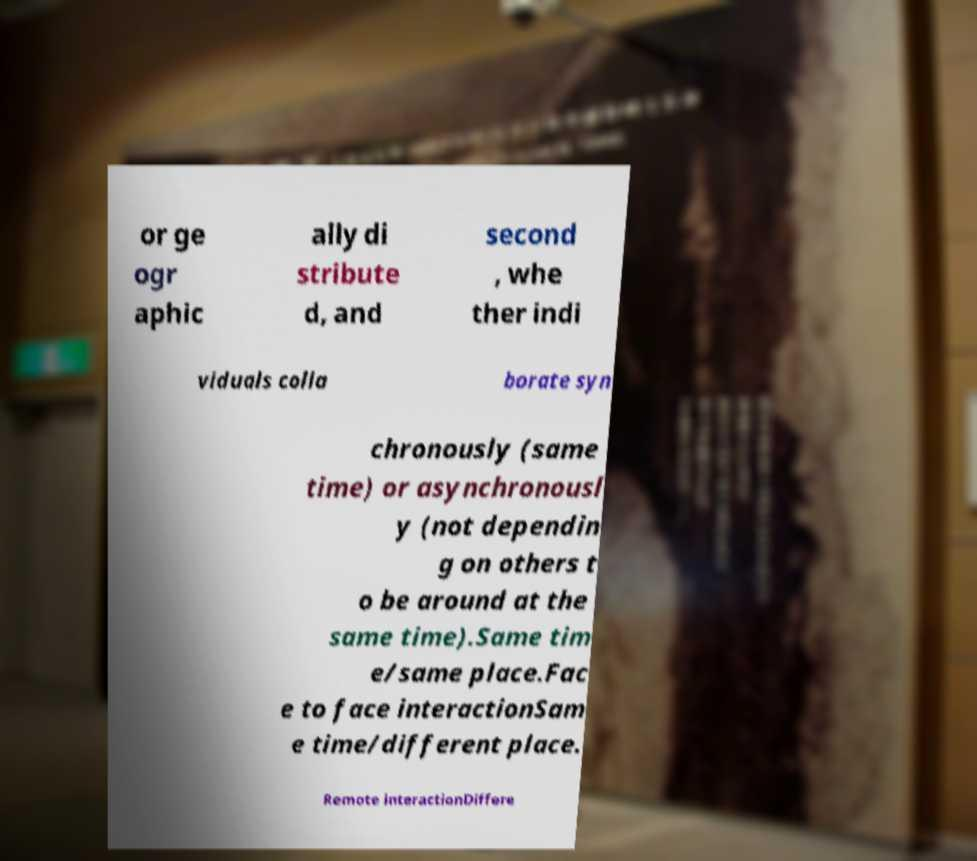Please identify and transcribe the text found in this image. or ge ogr aphic ally di stribute d, and second , whe ther indi viduals colla borate syn chronously (same time) or asynchronousl y (not dependin g on others t o be around at the same time).Same tim e/same place.Fac e to face interactionSam e time/different place. Remote interactionDiffere 